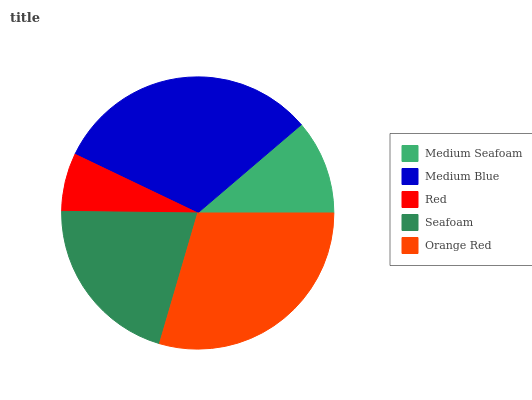Is Red the minimum?
Answer yes or no. Yes. Is Medium Blue the maximum?
Answer yes or no. Yes. Is Medium Blue the minimum?
Answer yes or no. No. Is Red the maximum?
Answer yes or no. No. Is Medium Blue greater than Red?
Answer yes or no. Yes. Is Red less than Medium Blue?
Answer yes or no. Yes. Is Red greater than Medium Blue?
Answer yes or no. No. Is Medium Blue less than Red?
Answer yes or no. No. Is Seafoam the high median?
Answer yes or no. Yes. Is Seafoam the low median?
Answer yes or no. Yes. Is Medium Seafoam the high median?
Answer yes or no. No. Is Medium Seafoam the low median?
Answer yes or no. No. 